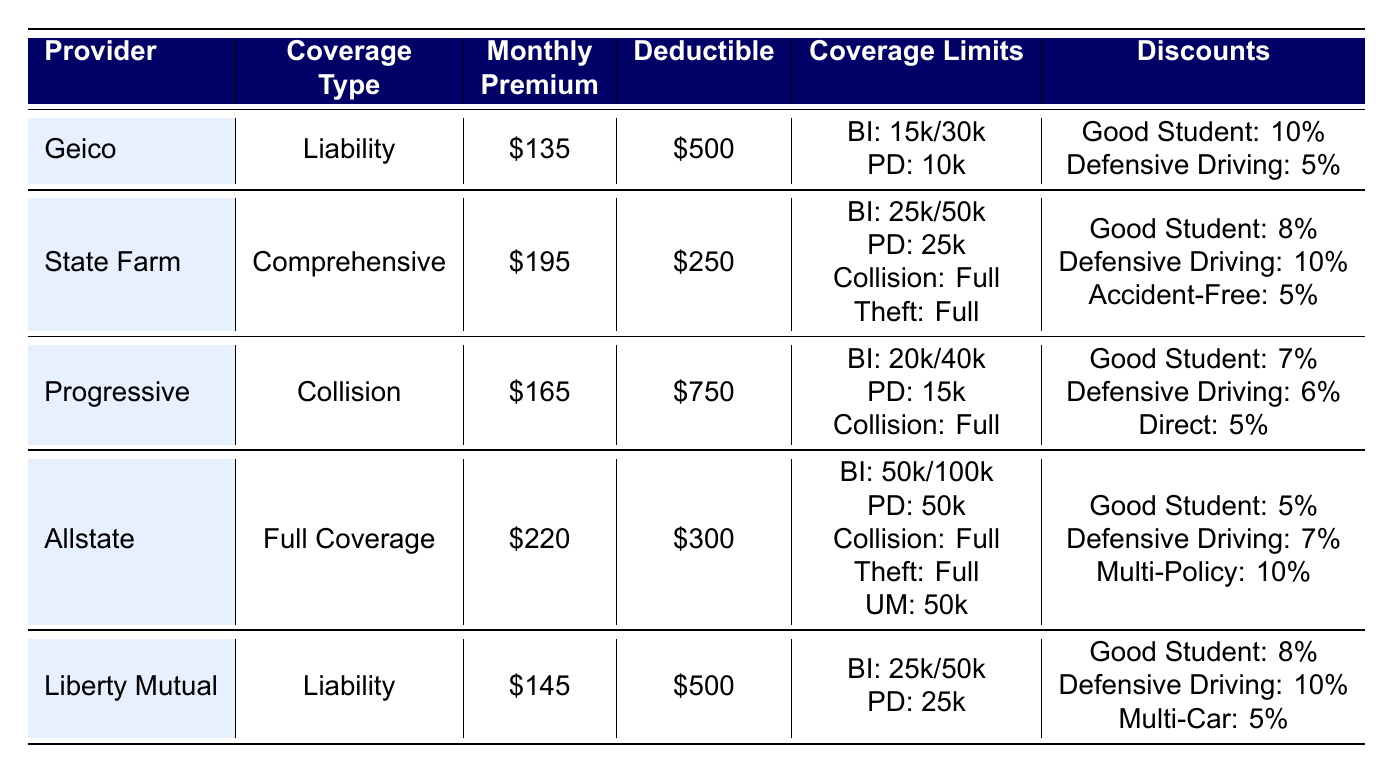What is the monthly premium for Geico? The table lists the monthly premium for Geico under the Monthly Premium column, which shows a value of 135.
Answer: 135 Which insurance provider has the highest monthly premium? By comparing the Monthly Premium column, Allstate has the highest value at 220, which is greater than the premiums of all other providers.
Answer: Allstate How much is the deductible for State Farm? The deductible for State Farm is indicated in the Deductible column, which shows a value of 250.
Answer: 250 True or false: Progressive offers a 6% discount for Defensive Driving. The table shows that Progressive offers a 6% discount under the Discounts column for Defensive Driving. Therefore, the statement is true.
Answer: True What is the total monthly premium for both Liability insurance options (Geico and Liberty Mutual)? The Monthly Premiums for Geico and Liberty Mutual are 135 and 145, respectively. Adding them together (135 + 145) gives a total of 280.
Answer: 280 Which provider offers a discount for accident-free driving? Looking through the Discounts column, State Farm has an “Accident-Free” discount listed at 5%, while none of the other providers offer this discount.
Answer: State Farm What is the average monthly premium of the three highest premium plans? The highest premiums are Allstate (220), State Farm (195), and Progressive (165). Summing these values (220 + 195 + 165 = 580) gives a total of 580, and there are three plans, so the average is 580 / 3 = 193.33.
Answer: 193.33 Which insurance provider has the lowest deductible with Comprehensive coverage? The only provider with Comprehensive coverage is State Farm, which has a deductible of 250. Since it is the only option for that coverage type, it is given as the lowest.
Answer: State Farm True or false: Allstate does not provide coverage for uninsured motorists. The table indicates that Allstate provides coverage for uninsured motorists (UM) with a limit of 50,000, making the statement false.
Answer: False 